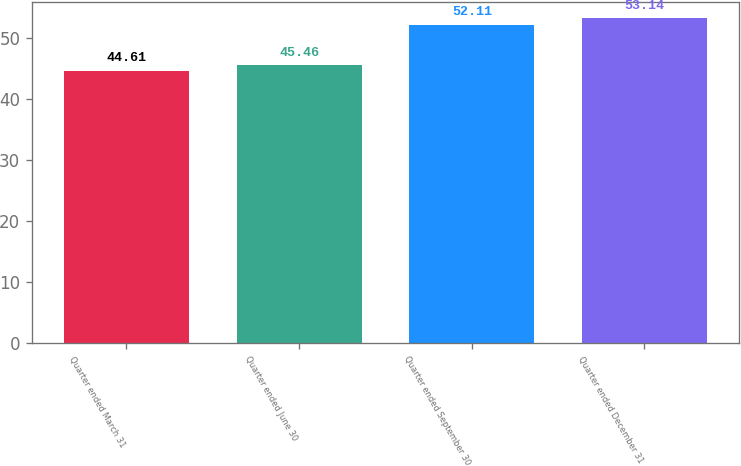Convert chart to OTSL. <chart><loc_0><loc_0><loc_500><loc_500><bar_chart><fcel>Quarter ended March 31<fcel>Quarter ended June 30<fcel>Quarter ended September 30<fcel>Quarter ended December 31<nl><fcel>44.61<fcel>45.46<fcel>52.11<fcel>53.14<nl></chart> 